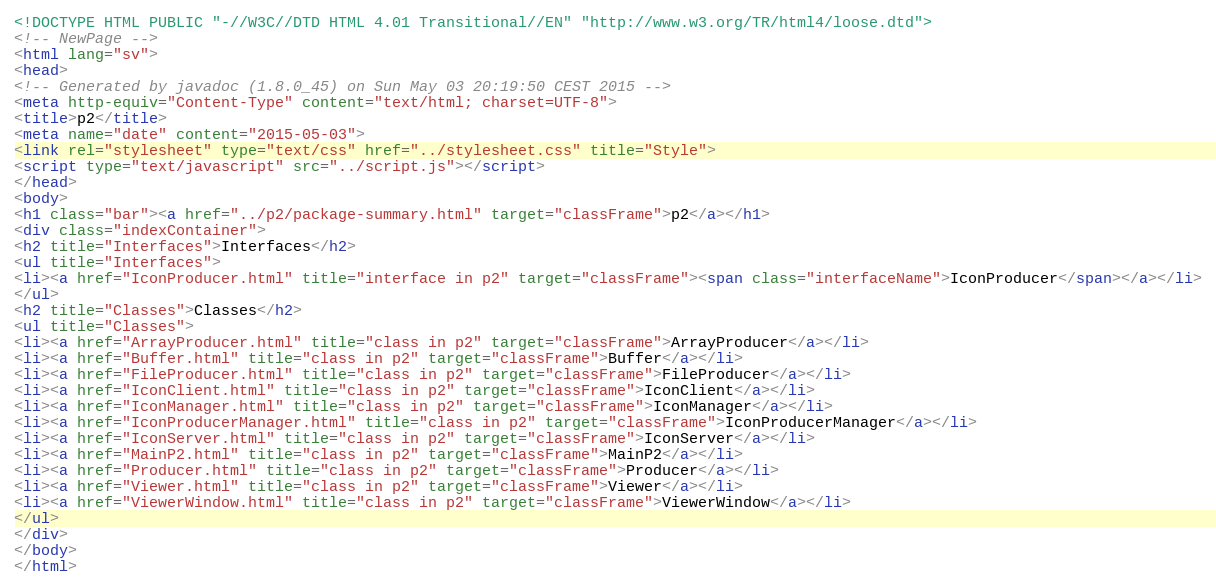Convert code to text. <code><loc_0><loc_0><loc_500><loc_500><_HTML_><!DOCTYPE HTML PUBLIC "-//W3C//DTD HTML 4.01 Transitional//EN" "http://www.w3.org/TR/html4/loose.dtd">
<!-- NewPage -->
<html lang="sv">
<head>
<!-- Generated by javadoc (1.8.0_45) on Sun May 03 20:19:50 CEST 2015 -->
<meta http-equiv="Content-Type" content="text/html; charset=UTF-8">
<title>p2</title>
<meta name="date" content="2015-05-03">
<link rel="stylesheet" type="text/css" href="../stylesheet.css" title="Style">
<script type="text/javascript" src="../script.js"></script>
</head>
<body>
<h1 class="bar"><a href="../p2/package-summary.html" target="classFrame">p2</a></h1>
<div class="indexContainer">
<h2 title="Interfaces">Interfaces</h2>
<ul title="Interfaces">
<li><a href="IconProducer.html" title="interface in p2" target="classFrame"><span class="interfaceName">IconProducer</span></a></li>
</ul>
<h2 title="Classes">Classes</h2>
<ul title="Classes">
<li><a href="ArrayProducer.html" title="class in p2" target="classFrame">ArrayProducer</a></li>
<li><a href="Buffer.html" title="class in p2" target="classFrame">Buffer</a></li>
<li><a href="FileProducer.html" title="class in p2" target="classFrame">FileProducer</a></li>
<li><a href="IconClient.html" title="class in p2" target="classFrame">IconClient</a></li>
<li><a href="IconManager.html" title="class in p2" target="classFrame">IconManager</a></li>
<li><a href="IconProducerManager.html" title="class in p2" target="classFrame">IconProducerManager</a></li>
<li><a href="IconServer.html" title="class in p2" target="classFrame">IconServer</a></li>
<li><a href="MainP2.html" title="class in p2" target="classFrame">MainP2</a></li>
<li><a href="Producer.html" title="class in p2" target="classFrame">Producer</a></li>
<li><a href="Viewer.html" title="class in p2" target="classFrame">Viewer</a></li>
<li><a href="ViewerWindow.html" title="class in p2" target="classFrame">ViewerWindow</a></li>
</ul>
</div>
</body>
</html>
</code> 